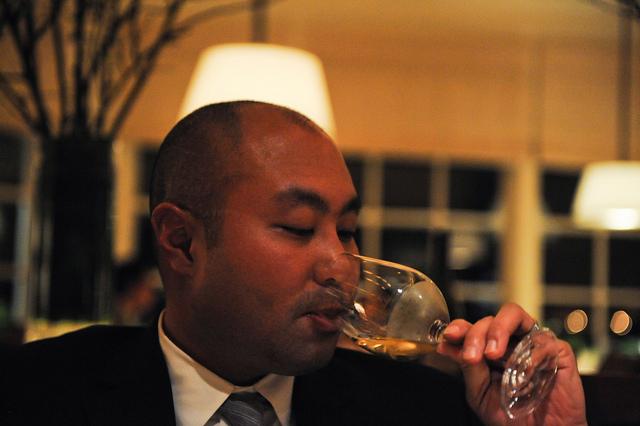What is the man holding?
Give a very brief answer. Wine glass. Is the man dressed in formal attire?
Quick response, please. Yes. Is the man drinking from a coke cola glass?
Answer briefly. No. What is the man eating?
Write a very short answer. Wine. Is the man getting drunk?
Short answer required. No. 